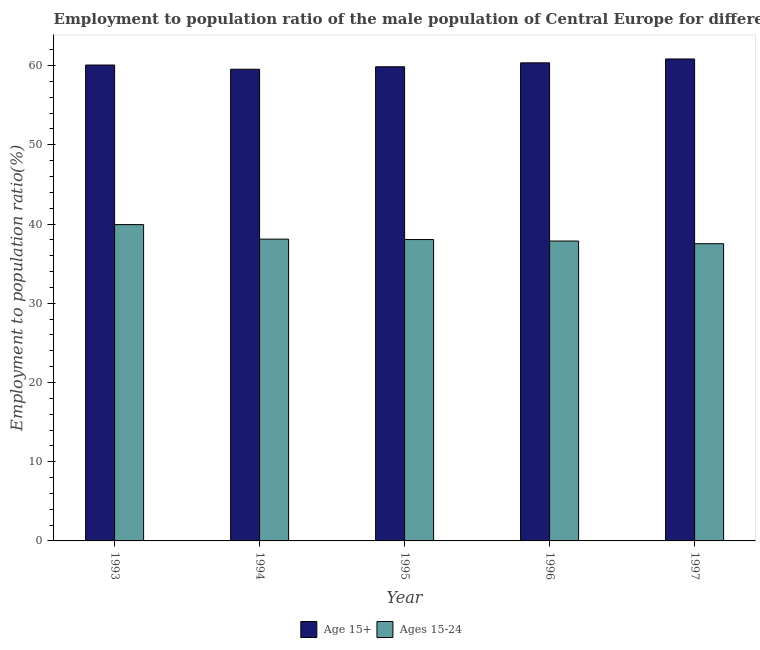Are the number of bars per tick equal to the number of legend labels?
Make the answer very short. Yes. How many bars are there on the 5th tick from the left?
Your answer should be very brief. 2. How many bars are there on the 4th tick from the right?
Make the answer very short. 2. In how many cases, is the number of bars for a given year not equal to the number of legend labels?
Your response must be concise. 0. What is the employment to population ratio(age 15+) in 1994?
Keep it short and to the point. 59.54. Across all years, what is the maximum employment to population ratio(age 15-24)?
Make the answer very short. 39.93. Across all years, what is the minimum employment to population ratio(age 15-24)?
Offer a terse response. 37.52. What is the total employment to population ratio(age 15+) in the graph?
Your answer should be very brief. 300.64. What is the difference between the employment to population ratio(age 15+) in 1996 and that in 1997?
Keep it short and to the point. -0.49. What is the difference between the employment to population ratio(age 15+) in 1994 and the employment to population ratio(age 15-24) in 1995?
Your answer should be compact. -0.31. What is the average employment to population ratio(age 15+) per year?
Keep it short and to the point. 60.13. In how many years, is the employment to population ratio(age 15+) greater than 26 %?
Offer a terse response. 5. What is the ratio of the employment to population ratio(age 15+) in 1994 to that in 1995?
Provide a short and direct response. 0.99. Is the difference between the employment to population ratio(age 15+) in 1993 and 1996 greater than the difference between the employment to population ratio(age 15-24) in 1993 and 1996?
Provide a succinct answer. No. What is the difference between the highest and the second highest employment to population ratio(age 15+)?
Offer a very short reply. 0.49. What is the difference between the highest and the lowest employment to population ratio(age 15-24)?
Give a very brief answer. 2.41. What does the 1st bar from the left in 1997 represents?
Give a very brief answer. Age 15+. What does the 1st bar from the right in 1997 represents?
Make the answer very short. Ages 15-24. How many bars are there?
Offer a very short reply. 10. How many years are there in the graph?
Your answer should be very brief. 5. What is the difference between two consecutive major ticks on the Y-axis?
Give a very brief answer. 10. Where does the legend appear in the graph?
Give a very brief answer. Bottom center. How many legend labels are there?
Ensure brevity in your answer.  2. What is the title of the graph?
Give a very brief answer. Employment to population ratio of the male population of Central Europe for different age-groups. Does "Time to import" appear as one of the legend labels in the graph?
Offer a terse response. No. What is the label or title of the X-axis?
Your answer should be compact. Year. What is the label or title of the Y-axis?
Offer a terse response. Employment to population ratio(%). What is the Employment to population ratio(%) of Age 15+ in 1993?
Ensure brevity in your answer.  60.07. What is the Employment to population ratio(%) of Ages 15-24 in 1993?
Ensure brevity in your answer.  39.93. What is the Employment to population ratio(%) in Age 15+ in 1994?
Make the answer very short. 59.54. What is the Employment to population ratio(%) in Ages 15-24 in 1994?
Keep it short and to the point. 38.09. What is the Employment to population ratio(%) in Age 15+ in 1995?
Your answer should be very brief. 59.85. What is the Employment to population ratio(%) of Ages 15-24 in 1995?
Give a very brief answer. 38.04. What is the Employment to population ratio(%) in Age 15+ in 1996?
Ensure brevity in your answer.  60.35. What is the Employment to population ratio(%) of Ages 15-24 in 1996?
Make the answer very short. 37.85. What is the Employment to population ratio(%) of Age 15+ in 1997?
Your answer should be very brief. 60.83. What is the Employment to population ratio(%) in Ages 15-24 in 1997?
Your answer should be very brief. 37.52. Across all years, what is the maximum Employment to population ratio(%) in Age 15+?
Provide a short and direct response. 60.83. Across all years, what is the maximum Employment to population ratio(%) in Ages 15-24?
Your answer should be very brief. 39.93. Across all years, what is the minimum Employment to population ratio(%) in Age 15+?
Offer a terse response. 59.54. Across all years, what is the minimum Employment to population ratio(%) of Ages 15-24?
Your answer should be very brief. 37.52. What is the total Employment to population ratio(%) in Age 15+ in the graph?
Provide a succinct answer. 300.64. What is the total Employment to population ratio(%) of Ages 15-24 in the graph?
Keep it short and to the point. 191.43. What is the difference between the Employment to population ratio(%) in Age 15+ in 1993 and that in 1994?
Ensure brevity in your answer.  0.53. What is the difference between the Employment to population ratio(%) in Ages 15-24 in 1993 and that in 1994?
Ensure brevity in your answer.  1.84. What is the difference between the Employment to population ratio(%) in Age 15+ in 1993 and that in 1995?
Your answer should be compact. 0.22. What is the difference between the Employment to population ratio(%) of Ages 15-24 in 1993 and that in 1995?
Keep it short and to the point. 1.89. What is the difference between the Employment to population ratio(%) of Age 15+ in 1993 and that in 1996?
Make the answer very short. -0.28. What is the difference between the Employment to population ratio(%) of Ages 15-24 in 1993 and that in 1996?
Keep it short and to the point. 2.08. What is the difference between the Employment to population ratio(%) in Age 15+ in 1993 and that in 1997?
Give a very brief answer. -0.76. What is the difference between the Employment to population ratio(%) in Ages 15-24 in 1993 and that in 1997?
Offer a terse response. 2.41. What is the difference between the Employment to population ratio(%) in Age 15+ in 1994 and that in 1995?
Your answer should be compact. -0.31. What is the difference between the Employment to population ratio(%) of Ages 15-24 in 1994 and that in 1995?
Your answer should be compact. 0.05. What is the difference between the Employment to population ratio(%) in Age 15+ in 1994 and that in 1996?
Ensure brevity in your answer.  -0.81. What is the difference between the Employment to population ratio(%) of Ages 15-24 in 1994 and that in 1996?
Give a very brief answer. 0.24. What is the difference between the Employment to population ratio(%) in Age 15+ in 1994 and that in 1997?
Your answer should be compact. -1.3. What is the difference between the Employment to population ratio(%) in Ages 15-24 in 1994 and that in 1997?
Provide a short and direct response. 0.58. What is the difference between the Employment to population ratio(%) of Age 15+ in 1995 and that in 1996?
Give a very brief answer. -0.5. What is the difference between the Employment to population ratio(%) in Ages 15-24 in 1995 and that in 1996?
Make the answer very short. 0.19. What is the difference between the Employment to population ratio(%) of Age 15+ in 1995 and that in 1997?
Your answer should be compact. -0.98. What is the difference between the Employment to population ratio(%) in Ages 15-24 in 1995 and that in 1997?
Make the answer very short. 0.52. What is the difference between the Employment to population ratio(%) of Age 15+ in 1996 and that in 1997?
Your answer should be very brief. -0.49. What is the difference between the Employment to population ratio(%) of Ages 15-24 in 1996 and that in 1997?
Ensure brevity in your answer.  0.34. What is the difference between the Employment to population ratio(%) of Age 15+ in 1993 and the Employment to population ratio(%) of Ages 15-24 in 1994?
Keep it short and to the point. 21.98. What is the difference between the Employment to population ratio(%) of Age 15+ in 1993 and the Employment to population ratio(%) of Ages 15-24 in 1995?
Offer a very short reply. 22.03. What is the difference between the Employment to population ratio(%) in Age 15+ in 1993 and the Employment to population ratio(%) in Ages 15-24 in 1996?
Offer a terse response. 22.22. What is the difference between the Employment to population ratio(%) in Age 15+ in 1993 and the Employment to population ratio(%) in Ages 15-24 in 1997?
Provide a short and direct response. 22.56. What is the difference between the Employment to population ratio(%) of Age 15+ in 1994 and the Employment to population ratio(%) of Ages 15-24 in 1995?
Give a very brief answer. 21.5. What is the difference between the Employment to population ratio(%) of Age 15+ in 1994 and the Employment to population ratio(%) of Ages 15-24 in 1996?
Make the answer very short. 21.69. What is the difference between the Employment to population ratio(%) in Age 15+ in 1994 and the Employment to population ratio(%) in Ages 15-24 in 1997?
Give a very brief answer. 22.02. What is the difference between the Employment to population ratio(%) of Age 15+ in 1995 and the Employment to population ratio(%) of Ages 15-24 in 1996?
Offer a terse response. 22. What is the difference between the Employment to population ratio(%) of Age 15+ in 1995 and the Employment to population ratio(%) of Ages 15-24 in 1997?
Your response must be concise. 22.33. What is the difference between the Employment to population ratio(%) in Age 15+ in 1996 and the Employment to population ratio(%) in Ages 15-24 in 1997?
Offer a terse response. 22.83. What is the average Employment to population ratio(%) of Age 15+ per year?
Offer a terse response. 60.13. What is the average Employment to population ratio(%) in Ages 15-24 per year?
Offer a very short reply. 38.29. In the year 1993, what is the difference between the Employment to population ratio(%) of Age 15+ and Employment to population ratio(%) of Ages 15-24?
Offer a very short reply. 20.14. In the year 1994, what is the difference between the Employment to population ratio(%) in Age 15+ and Employment to population ratio(%) in Ages 15-24?
Give a very brief answer. 21.45. In the year 1995, what is the difference between the Employment to population ratio(%) of Age 15+ and Employment to population ratio(%) of Ages 15-24?
Your answer should be very brief. 21.81. In the year 1996, what is the difference between the Employment to population ratio(%) in Age 15+ and Employment to population ratio(%) in Ages 15-24?
Keep it short and to the point. 22.49. In the year 1997, what is the difference between the Employment to population ratio(%) in Age 15+ and Employment to population ratio(%) in Ages 15-24?
Provide a succinct answer. 23.32. What is the ratio of the Employment to population ratio(%) of Age 15+ in 1993 to that in 1994?
Give a very brief answer. 1.01. What is the ratio of the Employment to population ratio(%) in Ages 15-24 in 1993 to that in 1994?
Provide a succinct answer. 1.05. What is the ratio of the Employment to population ratio(%) of Ages 15-24 in 1993 to that in 1995?
Give a very brief answer. 1.05. What is the ratio of the Employment to population ratio(%) of Ages 15-24 in 1993 to that in 1996?
Provide a succinct answer. 1.05. What is the ratio of the Employment to population ratio(%) in Age 15+ in 1993 to that in 1997?
Your response must be concise. 0.99. What is the ratio of the Employment to population ratio(%) in Ages 15-24 in 1993 to that in 1997?
Provide a succinct answer. 1.06. What is the ratio of the Employment to population ratio(%) of Age 15+ in 1994 to that in 1996?
Provide a succinct answer. 0.99. What is the ratio of the Employment to population ratio(%) of Ages 15-24 in 1994 to that in 1996?
Keep it short and to the point. 1.01. What is the ratio of the Employment to population ratio(%) in Age 15+ in 1994 to that in 1997?
Give a very brief answer. 0.98. What is the ratio of the Employment to population ratio(%) in Ages 15-24 in 1994 to that in 1997?
Provide a succinct answer. 1.02. What is the ratio of the Employment to population ratio(%) in Age 15+ in 1995 to that in 1996?
Your answer should be very brief. 0.99. What is the ratio of the Employment to population ratio(%) in Age 15+ in 1995 to that in 1997?
Keep it short and to the point. 0.98. What is the ratio of the Employment to population ratio(%) of Ages 15-24 in 1995 to that in 1997?
Make the answer very short. 1.01. What is the difference between the highest and the second highest Employment to population ratio(%) in Age 15+?
Ensure brevity in your answer.  0.49. What is the difference between the highest and the second highest Employment to population ratio(%) in Ages 15-24?
Ensure brevity in your answer.  1.84. What is the difference between the highest and the lowest Employment to population ratio(%) of Age 15+?
Provide a short and direct response. 1.3. What is the difference between the highest and the lowest Employment to population ratio(%) of Ages 15-24?
Provide a short and direct response. 2.41. 